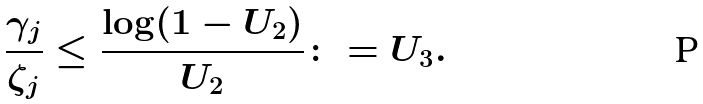Convert formula to latex. <formula><loc_0><loc_0><loc_500><loc_500>\frac { \gamma _ { j } } { \zeta _ { j } } \leq \frac { \log ( 1 - U _ { 2 } ) } { U _ { 2 } } \colon = U _ { 3 } .</formula> 